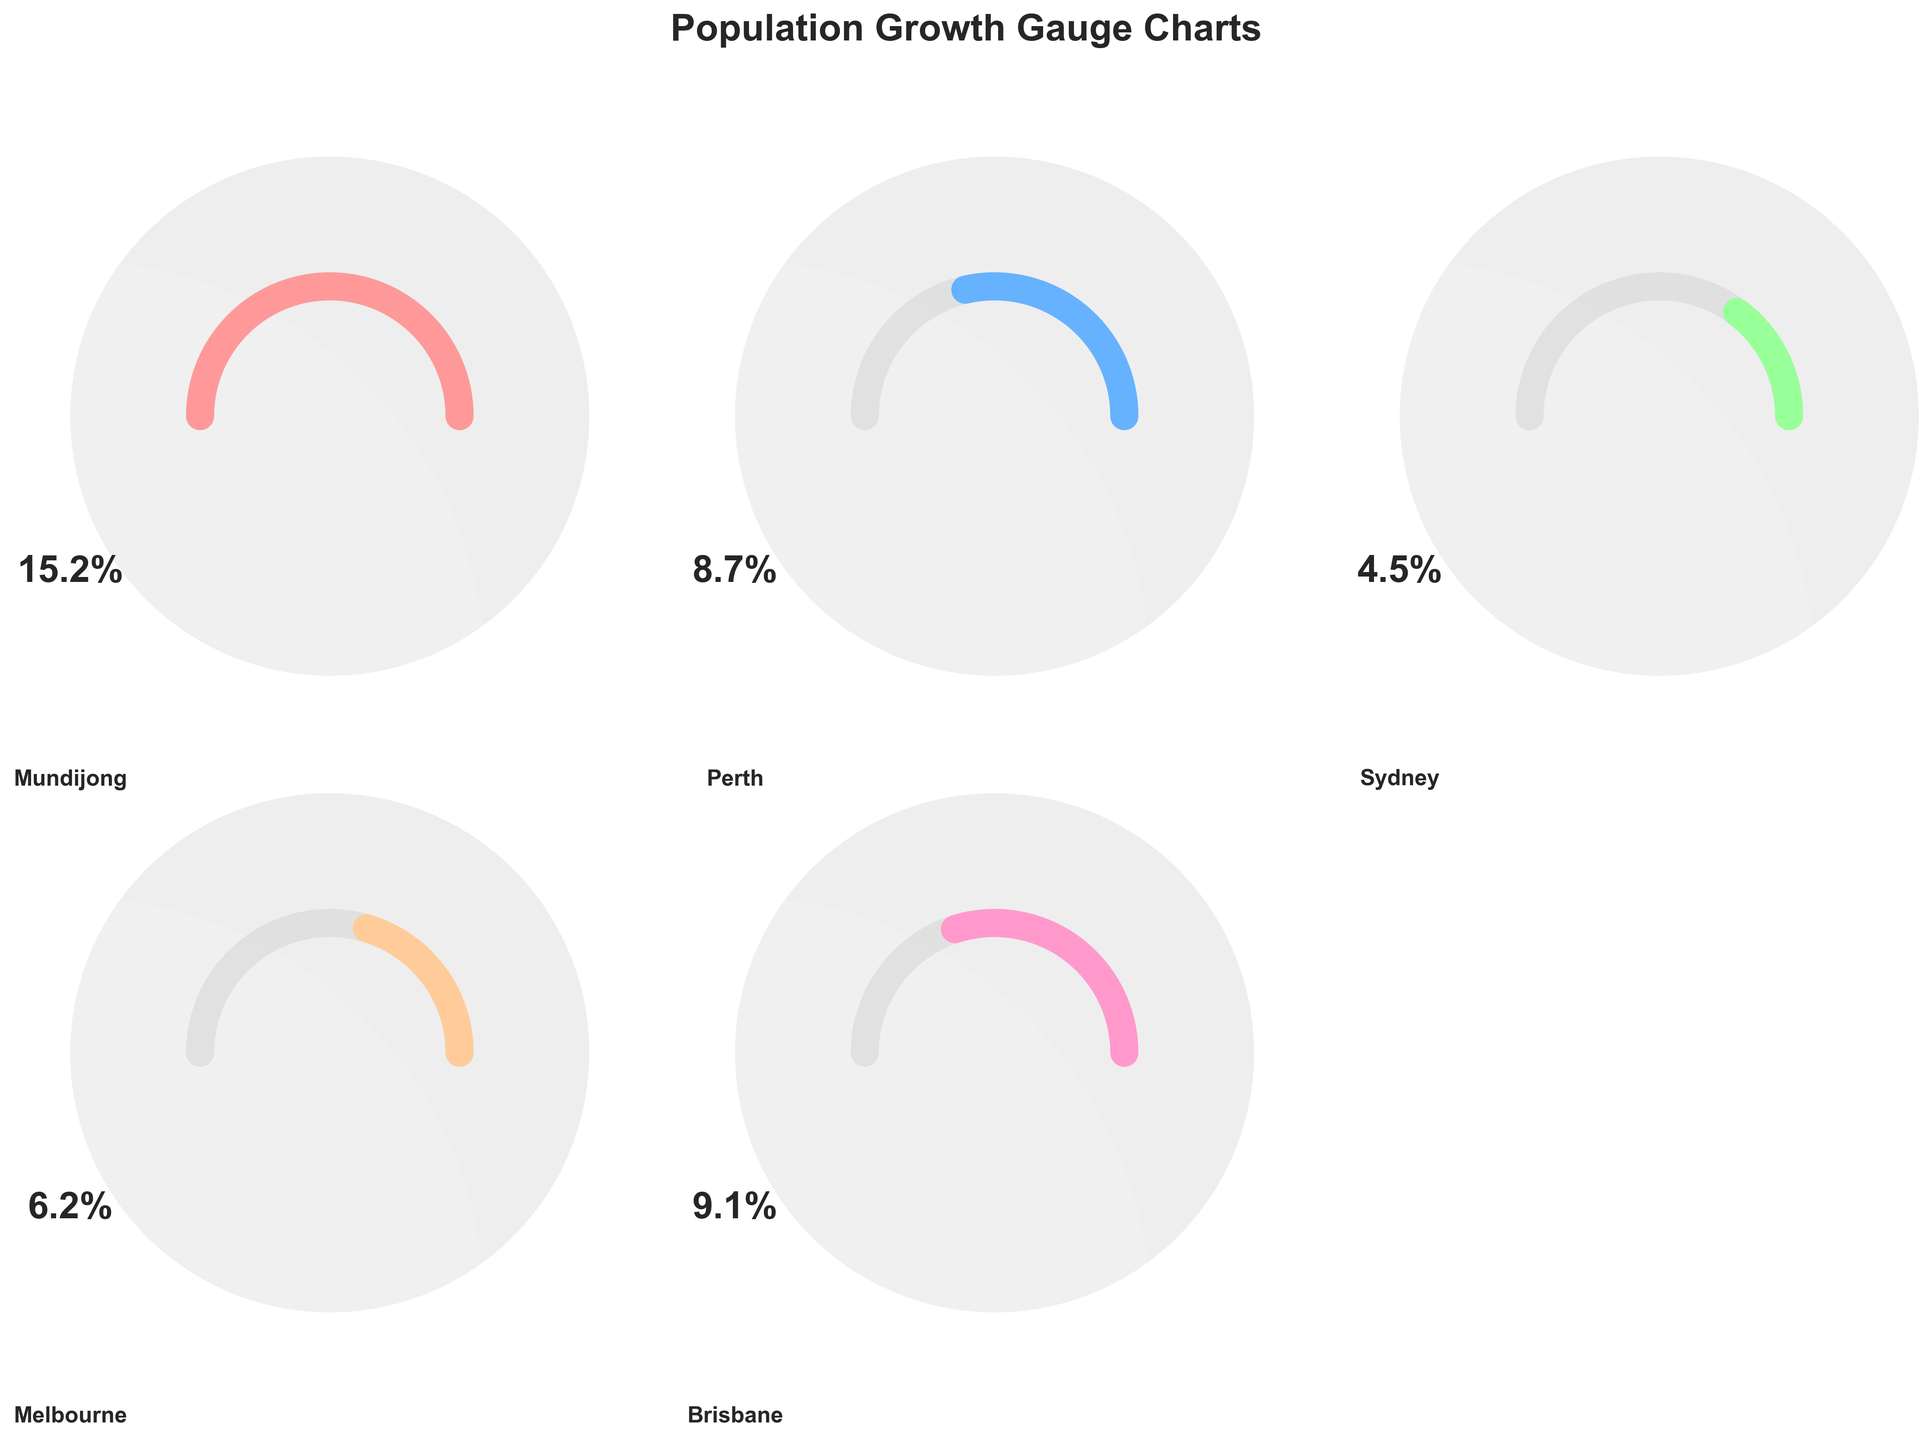What is the highest population growth percentage shown in the figure? The highest population growth percentage is identified by finding the city with the largest percentage value among all the presented cities. Here, Mundijong has the highest value of 15.2%.
Answer: 15.2% Which city has the lowest population growth percentage? To find the city with the lowest population growth, we look for the smallest percentage value among all the cities in the figure. Sydney has the lowest growth at 4.5%.
Answer: Sydney How many cities have a population growth percentage greater than 8%? We need to count the number of cities with population growth percentages greater than 8%. Mundijong, Perth, and Brisbane have growth rates above 8%.
Answer: 3 Which cities have a population growth percentage less than 10% but more than 5%? This involves checking the growth percentages of each city and identifying those between 5% and 10%. Perth, Melbourne, and Brisbane fall into this category.
Answer: Perth, Melbourne, Brisbane What is the difference in population growth percentage between Mundijong and Sydney? To calculate the difference, subtract Sydney's growth percentage from Mundijong's. This gives: 15.2% - 4.5% = 10.7%.
Answer: 10.7% How does the population growth percentage in Brisbane compare to Melbourne? Comparing the growth rates directly, Brisbane has a higher population growth percentage (9.1%) than Melbourne (6.2%).
Answer: Brisbane has a higher growth percentage What is the average population growth percentage of all the cities shown? Sum all growth percentages and divide by the number of cities: (15.2 + 8.7 + 4.5 + 6.2 + 9.1) / 5 = 43.7 / 5 = 8.74%.
Answer: 8.74% Which city has the second-highest population growth percentage? By sorting growth percentages, Brisbane has the second-highest growth with 9.1%, after Mundijong.
Answer: Brisbane What is the total population growth percentage for Perth and Brisbane combined? Add the growth percentages of Perth and Brisbane: 8.7% + 9.1% = 17.8%.
Answer: 17.8% Is the population growth percentage of Mundijong more than double that of Melbourne? Check if 15.2% is more than twice 6.2%. Double of Melbourne's growth is 12.4%, and 15.2% is indeed greater.
Answer: Yes 